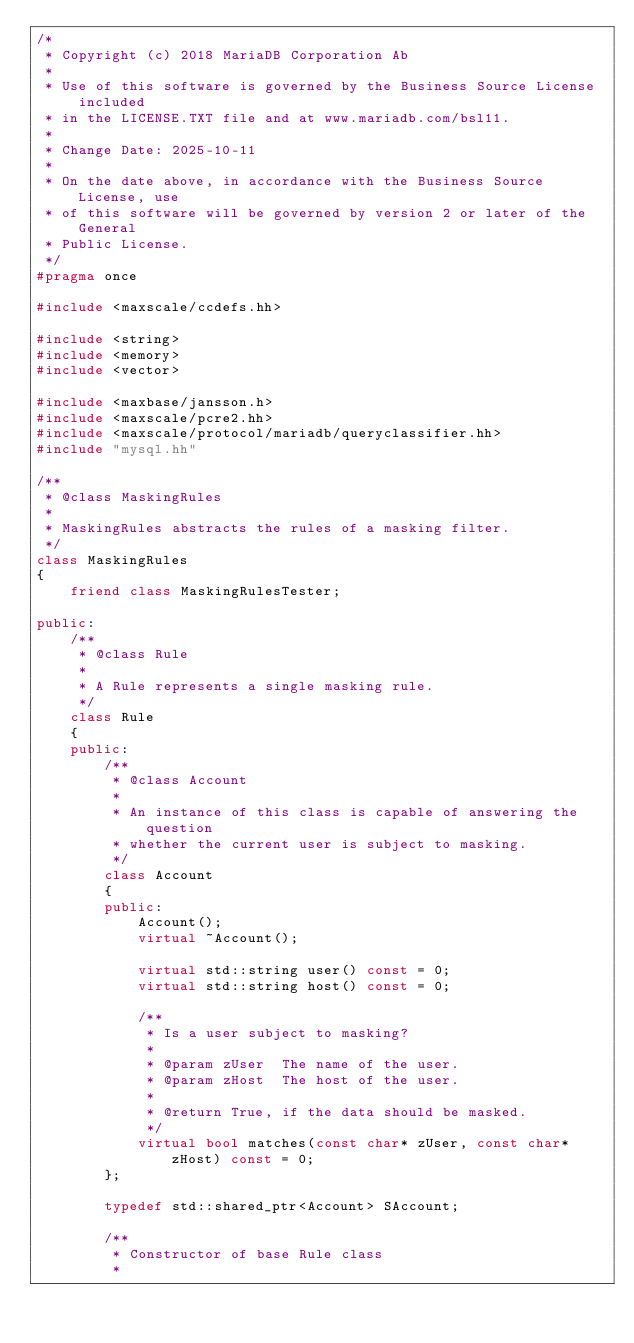Convert code to text. <code><loc_0><loc_0><loc_500><loc_500><_C++_>/*
 * Copyright (c) 2018 MariaDB Corporation Ab
 *
 * Use of this software is governed by the Business Source License included
 * in the LICENSE.TXT file and at www.mariadb.com/bsl11.
 *
 * Change Date: 2025-10-11
 *
 * On the date above, in accordance with the Business Source License, use
 * of this software will be governed by version 2 or later of the General
 * Public License.
 */
#pragma once

#include <maxscale/ccdefs.hh>

#include <string>
#include <memory>
#include <vector>

#include <maxbase/jansson.h>
#include <maxscale/pcre2.hh>
#include <maxscale/protocol/mariadb/queryclassifier.hh>
#include "mysql.hh"

/**
 * @class MaskingRules
 *
 * MaskingRules abstracts the rules of a masking filter.
 */
class MaskingRules
{
    friend class MaskingRulesTester;

public:
    /**
     * @class Rule
     *
     * A Rule represents a single masking rule.
     */
    class Rule
    {
    public:
        /**
         * @class Account
         *
         * An instance of this class is capable of answering the question
         * whether the current user is subject to masking.
         */
        class Account
        {
        public:
            Account();
            virtual ~Account();

            virtual std::string user() const = 0;
            virtual std::string host() const = 0;

            /**
             * Is a user subject to masking?
             *
             * @param zUser  The name of the user.
             * @param zHost  The host of the user.
             *
             * @return True, if the data should be masked.
             */
            virtual bool matches(const char* zUser, const char* zHost) const = 0;
        };

        typedef std::shared_ptr<Account> SAccount;

        /**
         * Constructor of base Rule class
         *</code> 